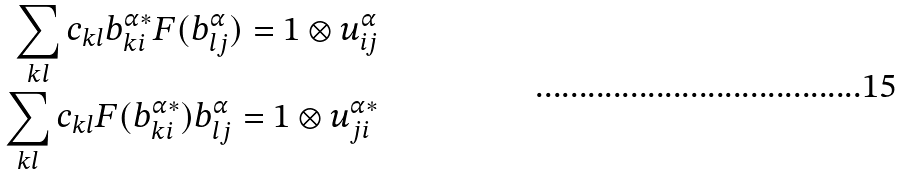Convert formula to latex. <formula><loc_0><loc_0><loc_500><loc_500>\sum _ { k l } c _ { k l } b _ { k i } ^ { \alpha * } F ( b _ { l j } ^ { \alpha } ) = 1 \otimes u ^ { \alpha } _ { i j } \\ \sum _ { k l } c _ { k l } F ( b _ { k i } ^ { \alpha * } ) b _ { l j } ^ { \alpha } = 1 \otimes u ^ { \alpha * } _ { j i }</formula> 